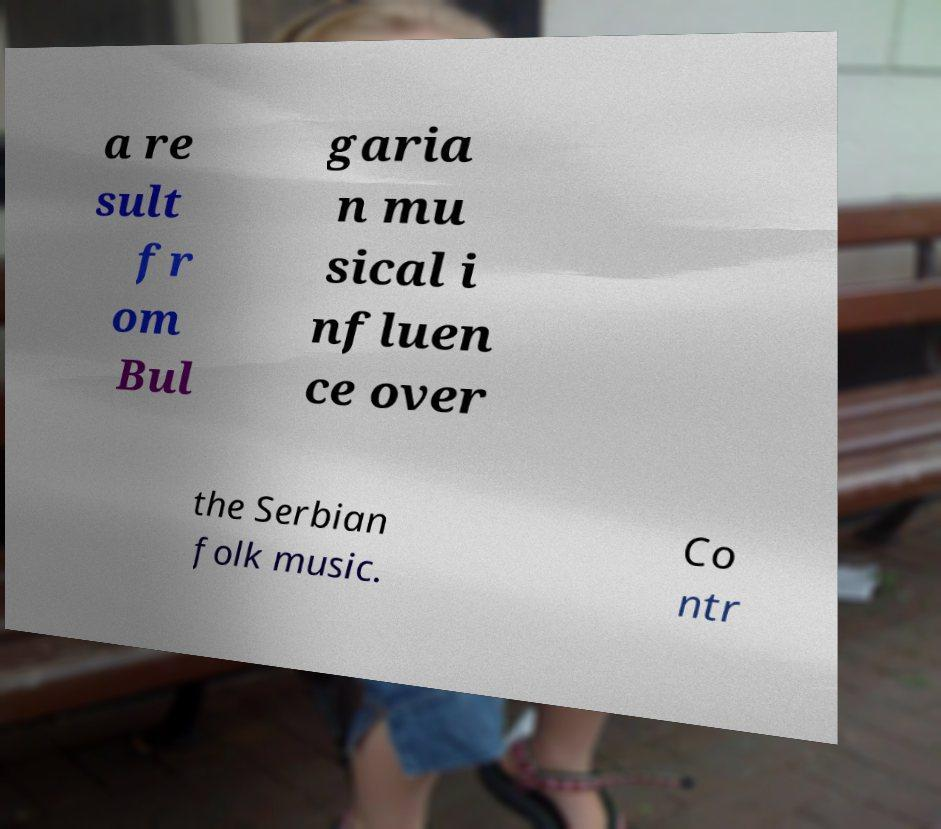Please identify and transcribe the text found in this image. a re sult fr om Bul garia n mu sical i nfluen ce over the Serbian folk music. Co ntr 